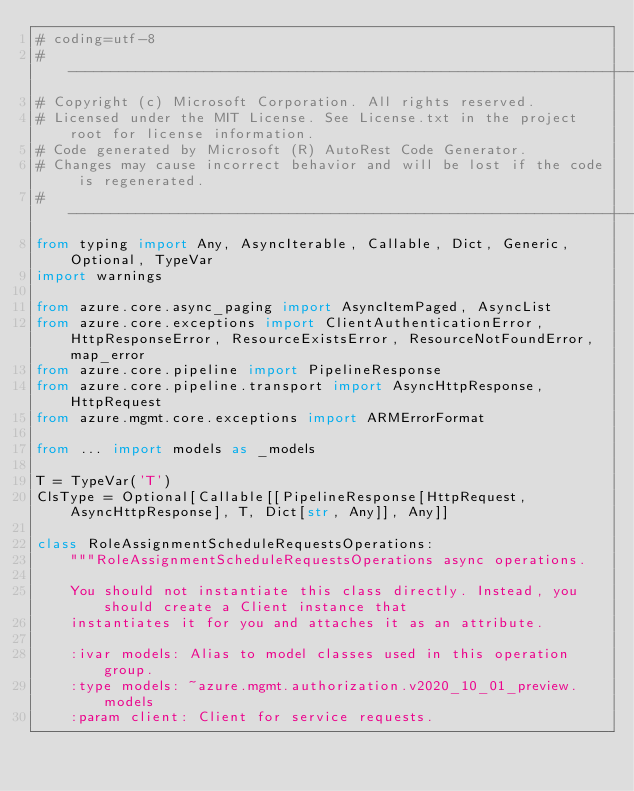Convert code to text. <code><loc_0><loc_0><loc_500><loc_500><_Python_># coding=utf-8
# --------------------------------------------------------------------------
# Copyright (c) Microsoft Corporation. All rights reserved.
# Licensed under the MIT License. See License.txt in the project root for license information.
# Code generated by Microsoft (R) AutoRest Code Generator.
# Changes may cause incorrect behavior and will be lost if the code is regenerated.
# --------------------------------------------------------------------------
from typing import Any, AsyncIterable, Callable, Dict, Generic, Optional, TypeVar
import warnings

from azure.core.async_paging import AsyncItemPaged, AsyncList
from azure.core.exceptions import ClientAuthenticationError, HttpResponseError, ResourceExistsError, ResourceNotFoundError, map_error
from azure.core.pipeline import PipelineResponse
from azure.core.pipeline.transport import AsyncHttpResponse, HttpRequest
from azure.mgmt.core.exceptions import ARMErrorFormat

from ... import models as _models

T = TypeVar('T')
ClsType = Optional[Callable[[PipelineResponse[HttpRequest, AsyncHttpResponse], T, Dict[str, Any]], Any]]

class RoleAssignmentScheduleRequestsOperations:
    """RoleAssignmentScheduleRequestsOperations async operations.

    You should not instantiate this class directly. Instead, you should create a Client instance that
    instantiates it for you and attaches it as an attribute.

    :ivar models: Alias to model classes used in this operation group.
    :type models: ~azure.mgmt.authorization.v2020_10_01_preview.models
    :param client: Client for service requests.</code> 